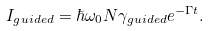<formula> <loc_0><loc_0><loc_500><loc_500>I _ { g u i d e d } = \hbar { \omega } _ { 0 } N \gamma _ { g u i d e d } e ^ { - \Gamma t } .</formula> 